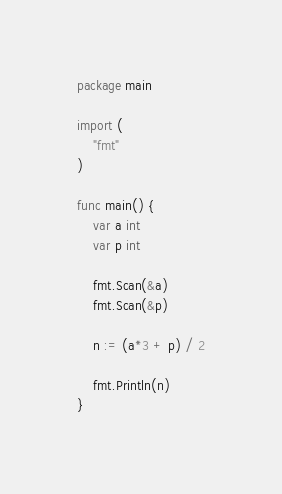Convert code to text. <code><loc_0><loc_0><loc_500><loc_500><_Go_>package main

import (
	"fmt"
)

func main() {
	var a int
	var p int

	fmt.Scan(&a)
	fmt.Scan(&p)

	n := (a*3 + p) / 2

	fmt.Println(n)
}
</code> 